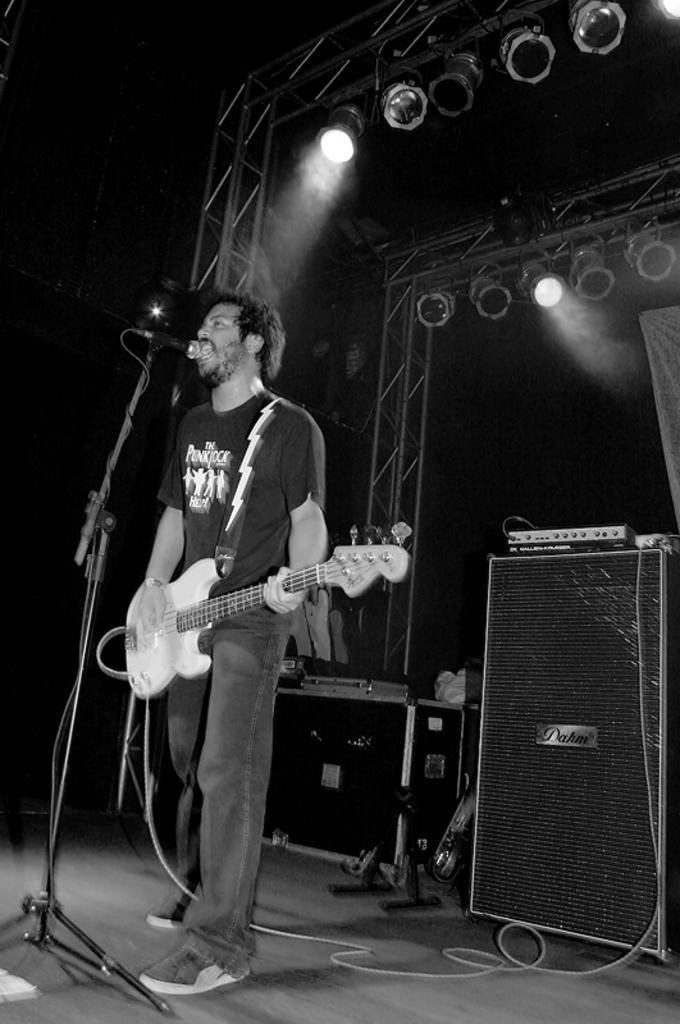Could you give a brief overview of what you see in this image? In the foreground of the image, there is one person standing in front of the mike and holding a guitar and playing it. On a rooftop there is a light fixed. In the background, there is a curtain and the speaker is kept on the table. This image is taken during night time. 